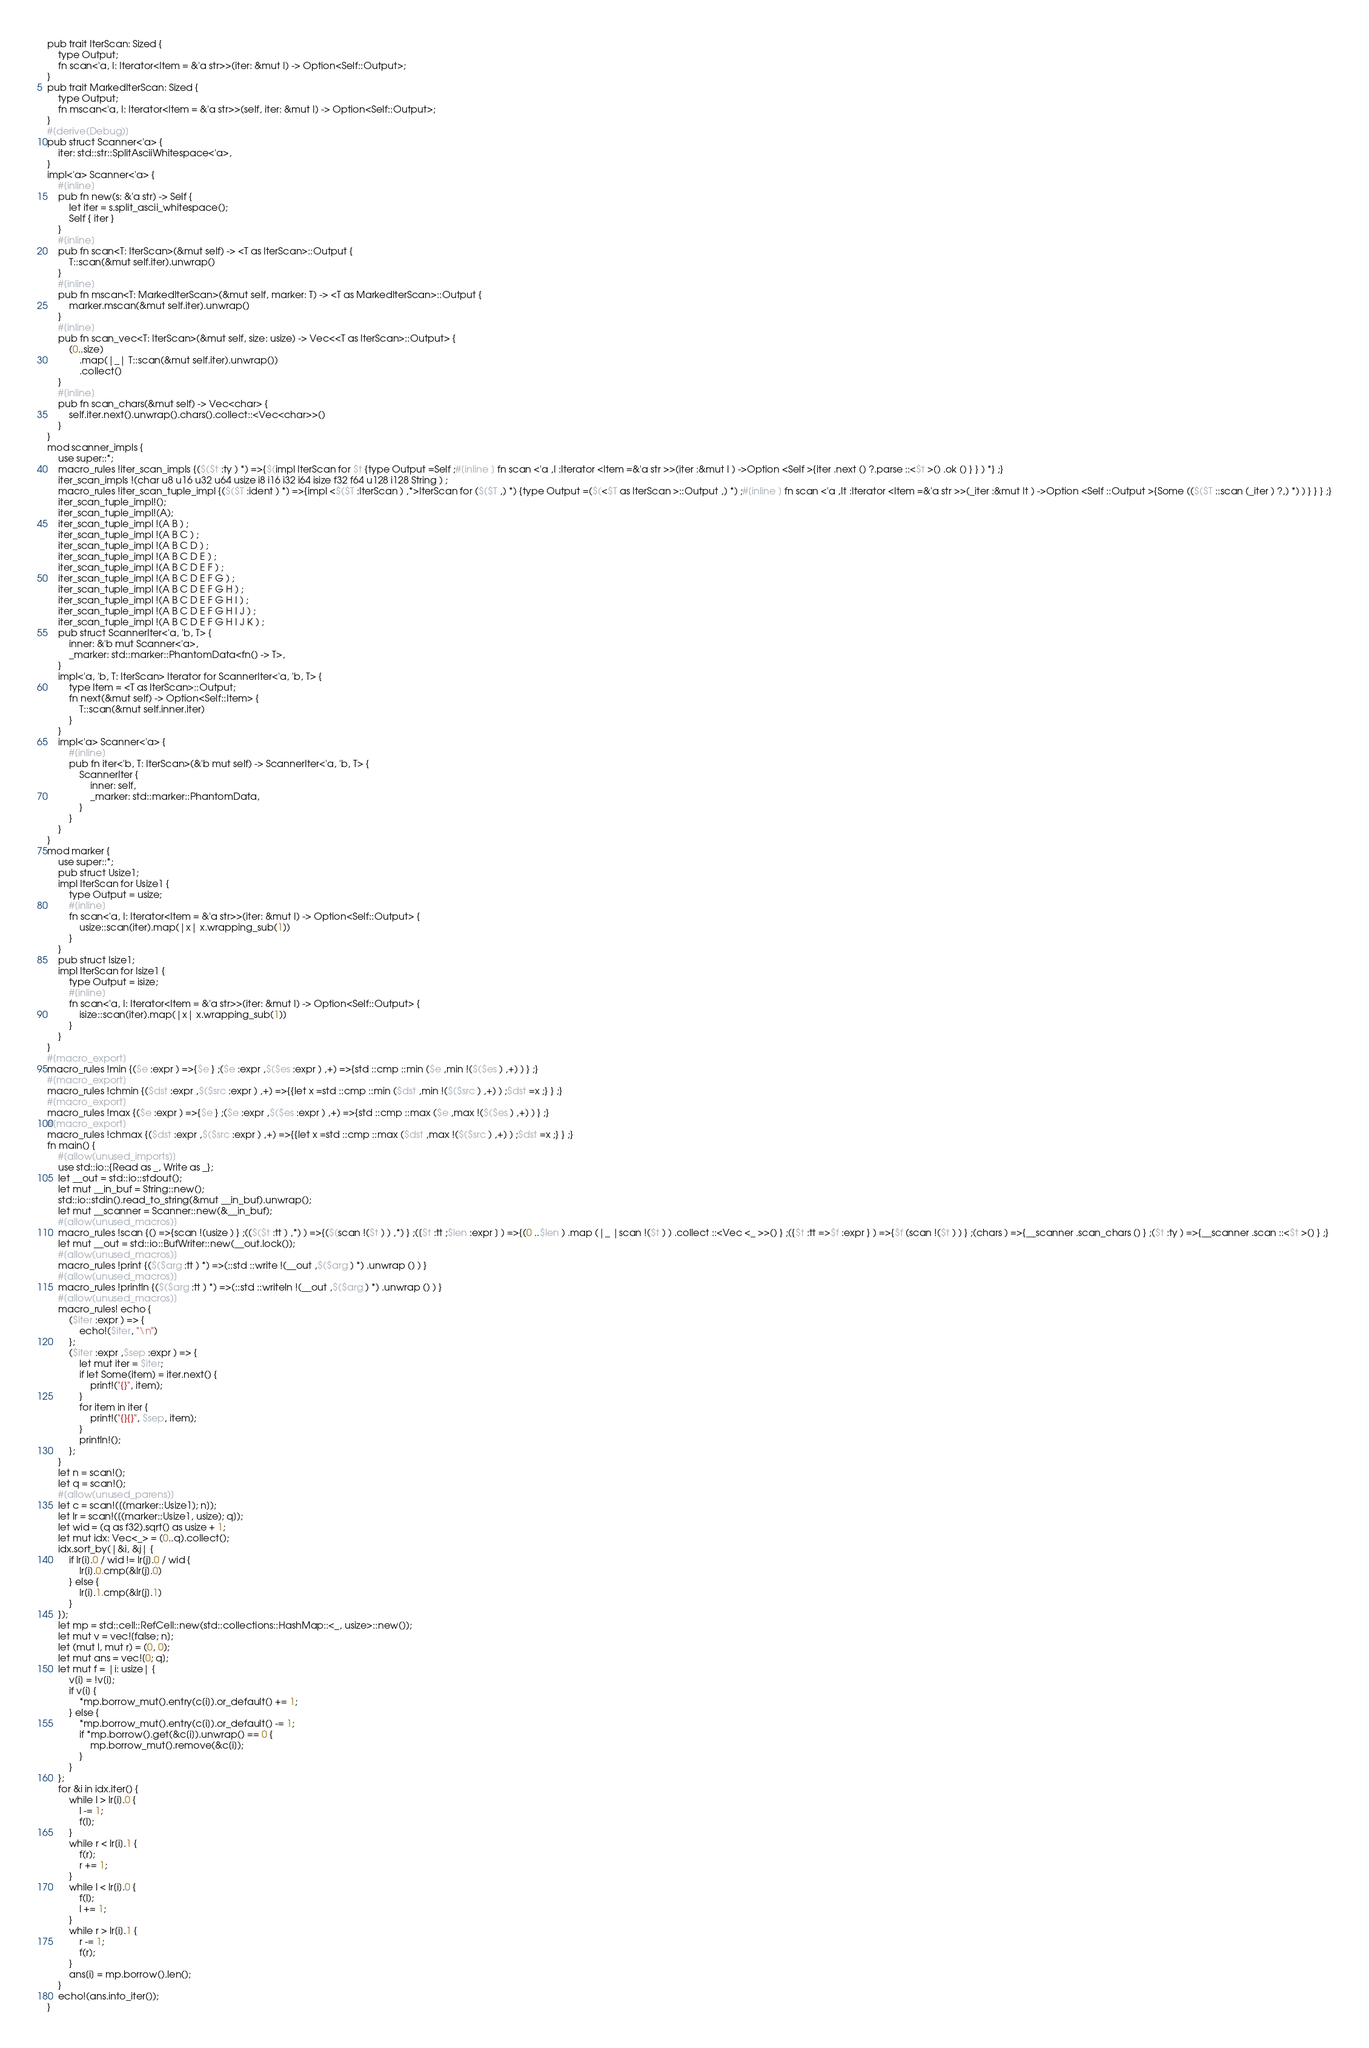Convert code to text. <code><loc_0><loc_0><loc_500><loc_500><_Rust_>pub trait IterScan: Sized {
    type Output;
    fn scan<'a, I: Iterator<Item = &'a str>>(iter: &mut I) -> Option<Self::Output>;
}
pub trait MarkedIterScan: Sized {
    type Output;
    fn mscan<'a, I: Iterator<Item = &'a str>>(self, iter: &mut I) -> Option<Self::Output>;
}
#[derive(Debug)]
pub struct Scanner<'a> {
    iter: std::str::SplitAsciiWhitespace<'a>,
}
impl<'a> Scanner<'a> {
    #[inline]
    pub fn new(s: &'a str) -> Self {
        let iter = s.split_ascii_whitespace();
        Self { iter }
    }
    #[inline]
    pub fn scan<T: IterScan>(&mut self) -> <T as IterScan>::Output {
        T::scan(&mut self.iter).unwrap()
    }
    #[inline]
    pub fn mscan<T: MarkedIterScan>(&mut self, marker: T) -> <T as MarkedIterScan>::Output {
        marker.mscan(&mut self.iter).unwrap()
    }
    #[inline]
    pub fn scan_vec<T: IterScan>(&mut self, size: usize) -> Vec<<T as IterScan>::Output> {
        (0..size)
            .map(|_| T::scan(&mut self.iter).unwrap())
            .collect()
    }
    #[inline]
    pub fn scan_chars(&mut self) -> Vec<char> {
        self.iter.next().unwrap().chars().collect::<Vec<char>>()
    }
}
mod scanner_impls {
    use super::*;
    macro_rules !iter_scan_impls {($($t :ty ) *) =>{$(impl IterScan for $t {type Output =Self ;#[inline ] fn scan <'a ,I :Iterator <Item =&'a str >>(iter :&mut I ) ->Option <Self >{iter .next () ?.parse ::<$t >() .ok () } } ) *} ;}
    iter_scan_impls !(char u8 u16 u32 u64 usize i8 i16 i32 i64 isize f32 f64 u128 i128 String ) ;
    macro_rules !iter_scan_tuple_impl {($($T :ident ) *) =>{impl <$($T :IterScan ) ,*>IterScan for ($($T ,) *) {type Output =($(<$T as IterScan >::Output ,) *) ;#[inline ] fn scan <'a ,It :Iterator <Item =&'a str >>(_iter :&mut It ) ->Option <Self ::Output >{Some (($($T ::scan (_iter ) ?,) *) ) } } } ;}
    iter_scan_tuple_impl!();
    iter_scan_tuple_impl!(A);
    iter_scan_tuple_impl !(A B ) ;
    iter_scan_tuple_impl !(A B C ) ;
    iter_scan_tuple_impl !(A B C D ) ;
    iter_scan_tuple_impl !(A B C D E ) ;
    iter_scan_tuple_impl !(A B C D E F ) ;
    iter_scan_tuple_impl !(A B C D E F G ) ;
    iter_scan_tuple_impl !(A B C D E F G H ) ;
    iter_scan_tuple_impl !(A B C D E F G H I ) ;
    iter_scan_tuple_impl !(A B C D E F G H I J ) ;
    iter_scan_tuple_impl !(A B C D E F G H I J K ) ;
    pub struct ScannerIter<'a, 'b, T> {
        inner: &'b mut Scanner<'a>,
        _marker: std::marker::PhantomData<fn() -> T>,
    }
    impl<'a, 'b, T: IterScan> Iterator for ScannerIter<'a, 'b, T> {
        type Item = <T as IterScan>::Output;
        fn next(&mut self) -> Option<Self::Item> {
            T::scan(&mut self.inner.iter)
        }
    }
    impl<'a> Scanner<'a> {
        #[inline]
        pub fn iter<'b, T: IterScan>(&'b mut self) -> ScannerIter<'a, 'b, T> {
            ScannerIter {
                inner: self,
                _marker: std::marker::PhantomData,
            }
        }
    }
}
mod marker {
    use super::*;
    pub struct Usize1;
    impl IterScan for Usize1 {
        type Output = usize;
        #[inline]
        fn scan<'a, I: Iterator<Item = &'a str>>(iter: &mut I) -> Option<Self::Output> {
            usize::scan(iter).map(|x| x.wrapping_sub(1))
        }
    }
    pub struct Isize1;
    impl IterScan for Isize1 {
        type Output = isize;
        #[inline]
        fn scan<'a, I: Iterator<Item = &'a str>>(iter: &mut I) -> Option<Self::Output> {
            isize::scan(iter).map(|x| x.wrapping_sub(1))
        }
    }
}
#[macro_export]
macro_rules !min {($e :expr ) =>{$e } ;($e :expr ,$($es :expr ) ,+) =>{std ::cmp ::min ($e ,min !($($es ) ,+) ) } ;}
#[macro_export]
macro_rules !chmin {($dst :expr ,$($src :expr ) ,+) =>{{let x =std ::cmp ::min ($dst ,min !($($src ) ,+) ) ;$dst =x ;} } ;}
#[macro_export]
macro_rules !max {($e :expr ) =>{$e } ;($e :expr ,$($es :expr ) ,+) =>{std ::cmp ::max ($e ,max !($($es ) ,+) ) } ;}
#[macro_export]
macro_rules !chmax {($dst :expr ,$($src :expr ) ,+) =>{{let x =std ::cmp ::max ($dst ,max !($($src ) ,+) ) ;$dst =x ;} } ;}
fn main() {
    #[allow(unused_imports)]
    use std::io::{Read as _, Write as _};
    let __out = std::io::stdout();
    let mut __in_buf = String::new();
    std::io::stdin().read_to_string(&mut __in_buf).unwrap();
    let mut __scanner = Scanner::new(&__in_buf);
    #[allow(unused_macros)]
    macro_rules !scan {() =>{scan !(usize ) } ;(($($t :tt ) ,*) ) =>{($(scan !($t ) ) ,*) } ;([$t :tt ;$len :expr ] ) =>{(0 ..$len ) .map (|_ |scan !($t ) ) .collect ::<Vec <_ >>() } ;({$t :tt =>$f :expr } ) =>{$f (scan !($t ) ) } ;(chars ) =>{__scanner .scan_chars () } ;($t :ty ) =>{__scanner .scan ::<$t >() } ;}
    let mut __out = std::io::BufWriter::new(__out.lock());
    #[allow(unused_macros)]
    macro_rules !print {($($arg :tt ) *) =>(::std ::write !(__out ,$($arg ) *) .unwrap () ) }
    #[allow(unused_macros)]
    macro_rules !println {($($arg :tt ) *) =>(::std ::writeln !(__out ,$($arg ) *) .unwrap () ) }
    #[allow(unused_macros)]
    macro_rules! echo {
        ($iter :expr ) => {
            echo!($iter, "\n")
        };
        ($iter :expr ,$sep :expr ) => {
            let mut iter = $iter;
            if let Some(item) = iter.next() {
                print!("{}", item);
            }
            for item in iter {
                print!("{}{}", $sep, item);
            }
            println!();
        };
    }
    let n = scan!();
    let q = scan!();
    #[allow(unused_parens)]
    let c = scan!([(marker::Usize1); n]);
    let lr = scan!([(marker::Usize1, usize); q]);
    let wid = (q as f32).sqrt() as usize + 1;
    let mut idx: Vec<_> = (0..q).collect();
    idx.sort_by(|&i, &j| {
        if lr[i].0 / wid != lr[j].0 / wid {
            lr[i].0.cmp(&lr[j].0)
        } else {
            lr[i].1.cmp(&lr[j].1)
        }
    });
    let mp = std::cell::RefCell::new(std::collections::HashMap::<_, usize>::new());
    let mut v = vec![false; n];
    let (mut l, mut r) = (0, 0);
    let mut ans = vec![0; q];
    let mut f = |i: usize| {
        v[i] = !v[i];
        if v[i] {
            *mp.borrow_mut().entry(c[i]).or_default() += 1;
        } else {
            *mp.borrow_mut().entry(c[i]).or_default() -= 1;
            if *mp.borrow().get(&c[i]).unwrap() == 0 {
                mp.borrow_mut().remove(&c[i]);
            }
        }
    };
    for &i in idx.iter() {
        while l > lr[i].0 {
            l -= 1;
            f(l);
        }
        while r < lr[i].1 {
            f(r);
            r += 1;
        }
        while l < lr[i].0 {
            f(l);
            l += 1;
        }
        while r > lr[i].1 {
            r -= 1;
            f(r);
        }
        ans[i] = mp.borrow().len();
    }
    echo!(ans.into_iter());
}</code> 